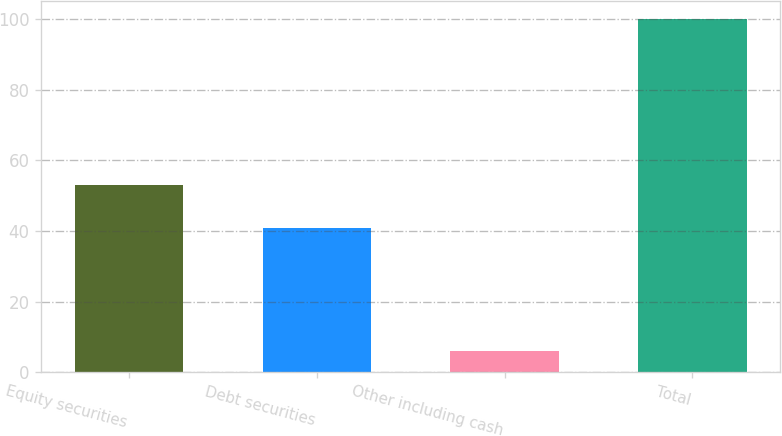Convert chart to OTSL. <chart><loc_0><loc_0><loc_500><loc_500><bar_chart><fcel>Equity securities<fcel>Debt securities<fcel>Other including cash<fcel>Total<nl><fcel>53<fcel>41<fcel>6<fcel>100<nl></chart> 